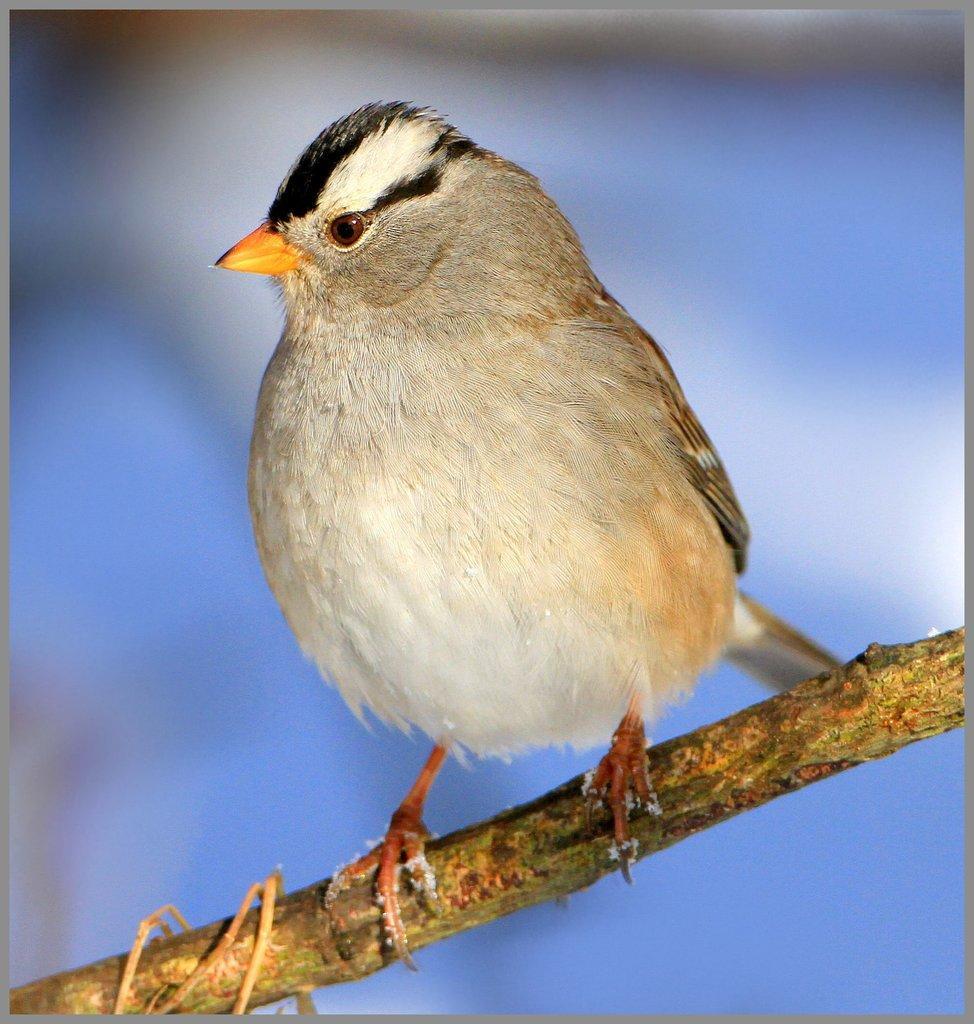Describe this image in one or two sentences. This is an edited picture. In this image there is a bird standing on the tree branch. At the back image is blurry. 